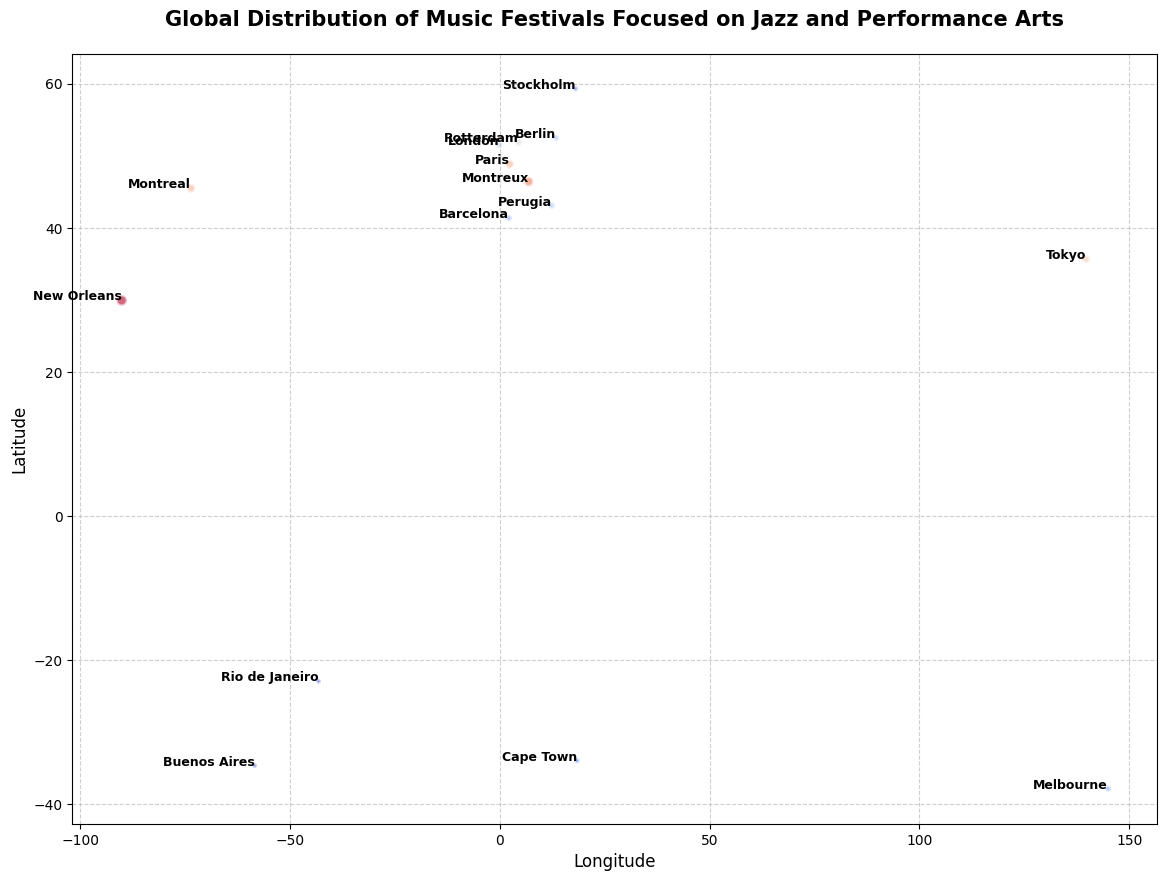Which city has the largest number of jazz and performance arts festivals? We can identify the largest bubble on the chart, which represents the city with the most festivals. The city with the largest bubble is New Orleans, indicated by the data.
Answer: New Orleans Which country has the highest number of cities listed in the figure? By counting the number of cities from each country, we find that the United States has the highest number of cities, specifically New Orleans. Other countries have only one city listed each.
Answer: United States What city located in Europe has the second highest number of festivals? We need to look at the bubbles in Europe and find the one with the second largest size. Paris has 10 festivals while Montreux has 12, so Montreux is the city with the second highest number of festivals.
Answer: Montreux What is the total number of festivals in North America? We sum the number of festivals in North American cities: New Orleans (15), Montreal (10), and Mexico City (7). This gives a total of 15 + 10 + 7 = 32.
Answer: 32 Which city in the Southern Hemisphere has the highest number of festivals? We identify cities in the Southern Hemisphere by their negative latitude values and look for the one with the largest bubble. Melbourne, listed with 5 festivals, has the highest number in the Southern Hemisphere.
Answer: Melbourne Compare the number of festivals between Tokyo and Berlin. Which city has more festivals, and by how much? From the chart, Tokyo has 9 festivals and Berlin has 6. The difference is 9 - 6 = 3 festivals.
Answer: Tokyo by 3 festivals Which two cities have an equal number of festivals? By examining the bubbles and the annotations, we see that Perugia and Berlin each have 6 festivals, showing the equal number of festivals between these two cities.
Answer: Perugia and Berlin What is the average number of festivals across all the cities shown in the chart? First, sum the number of festivals in all cities: 15 + 12 + 10 + 8 + 6 + 9 + 7 + 6 + 10 + 5 + 4 + 3 + 5 + 4 + 3 = 107. Then, divide by the number of cities: 107 / 15 ≈ 7.13.
Answer: Approximately 7.13 How does the number of festivals in Montreux compare to Montreal and what is the numerical difference? According to the chart, Montreux has 12 festivals, and Montreal has 10. The numerical difference is 12 - 10 = 2 festivals.
Answer: Montreux has 2 more festivals Which city between Barcelona and Stockholm has fewer festivals and what is the count? From the chart, Barcelona has 5 festivals and Stockholm has 4. Therefore, Stockholm has fewer festivals.
Answer: Stockholm with 4 festivals 